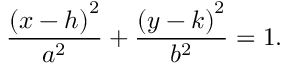<formula> <loc_0><loc_0><loc_500><loc_500>{ \frac { \left ( x - h \right ) ^ { 2 } } { a ^ { 2 } } } + { \frac { \left ( y - k \right ) ^ { 2 } } { b ^ { 2 } } } = 1 .</formula> 